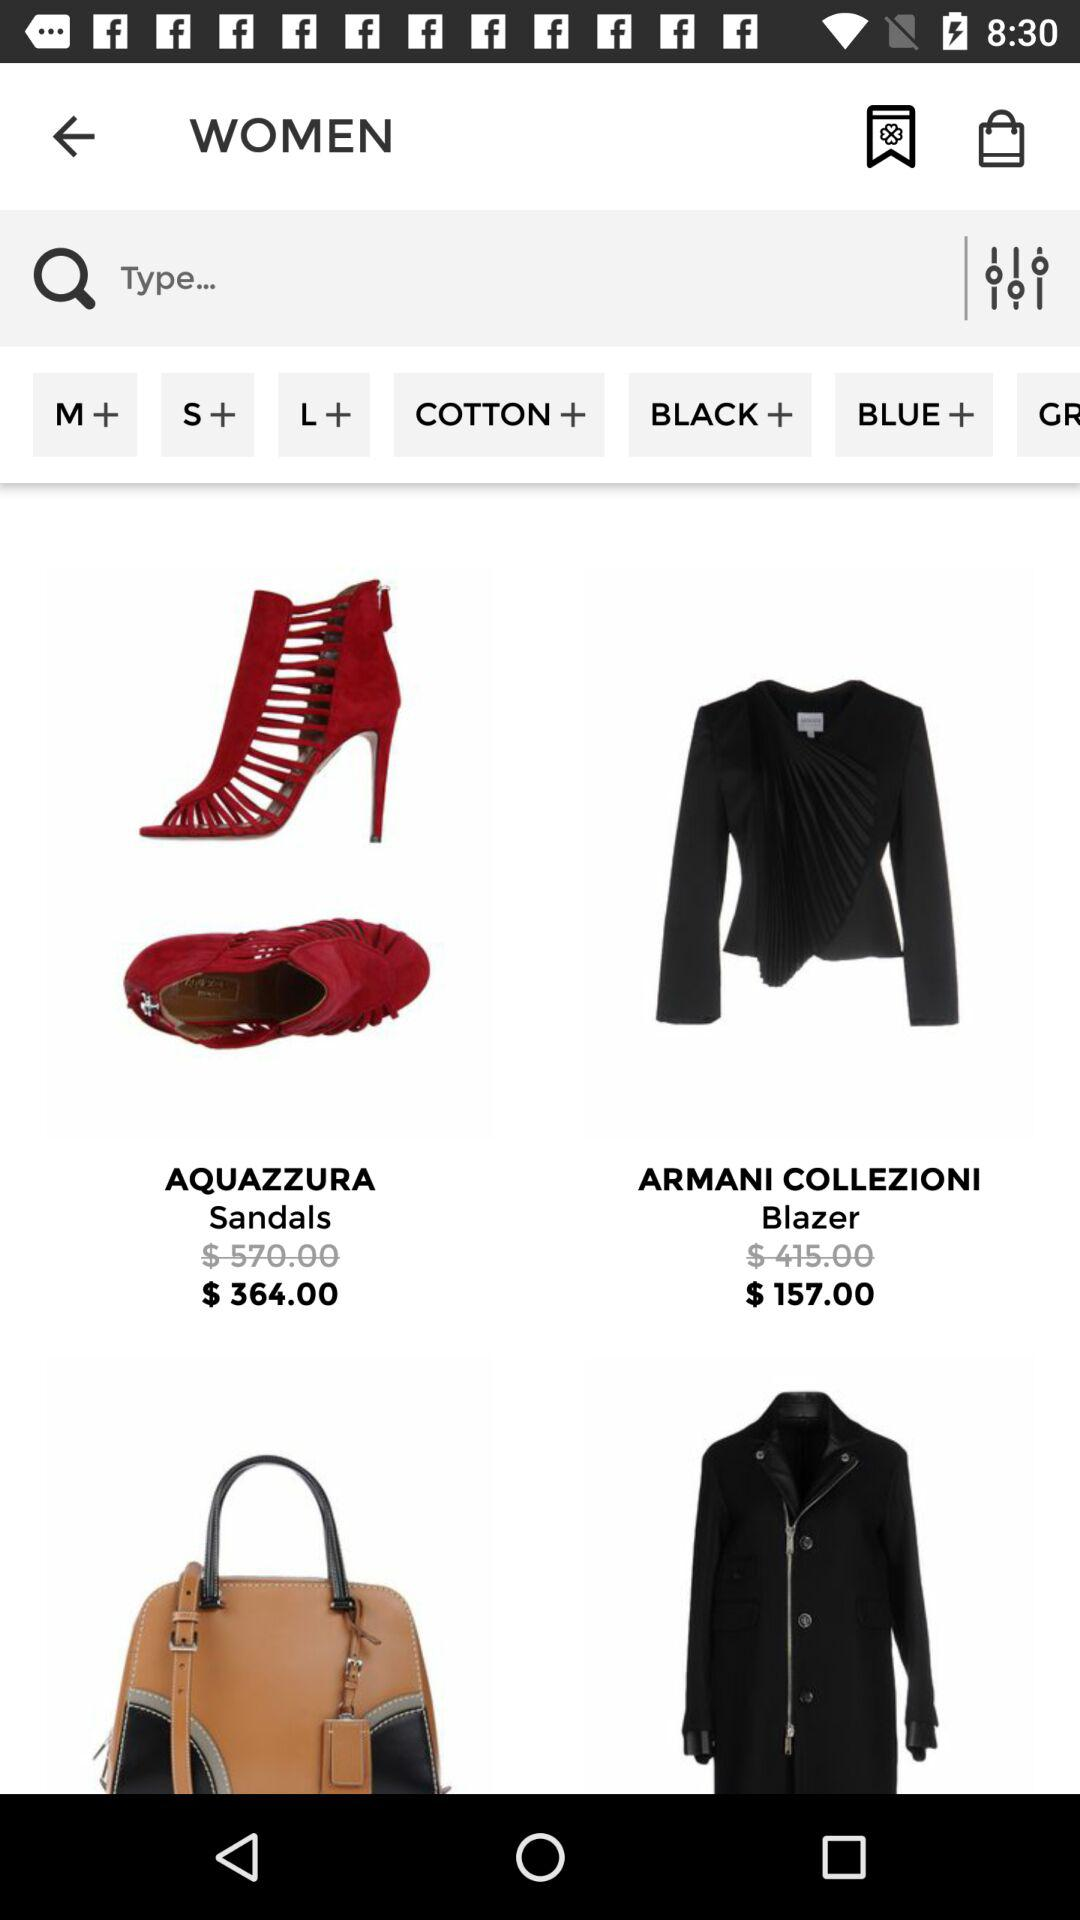What is the price of the "Armani Collezezioni Blazer"? The price is $157.00. 